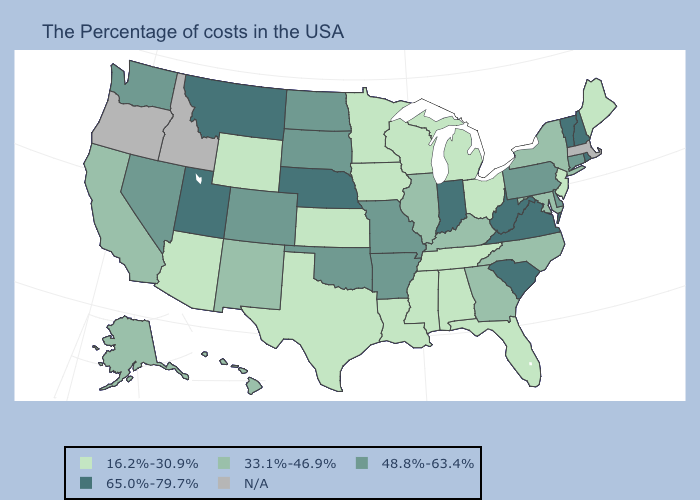What is the value of Illinois?
Give a very brief answer. 33.1%-46.9%. Is the legend a continuous bar?
Be succinct. No. Name the states that have a value in the range N/A?
Keep it brief. Massachusetts, Idaho, Oregon. Which states hav the highest value in the South?
Keep it brief. Virginia, South Carolina, West Virginia. What is the lowest value in states that border Maine?
Short answer required. 65.0%-79.7%. Among the states that border Michigan , does Wisconsin have the highest value?
Concise answer only. No. Name the states that have a value in the range 48.8%-63.4%?
Quick response, please. Connecticut, Delaware, Pennsylvania, Missouri, Arkansas, Oklahoma, South Dakota, North Dakota, Colorado, Nevada, Washington. Name the states that have a value in the range 48.8%-63.4%?
Concise answer only. Connecticut, Delaware, Pennsylvania, Missouri, Arkansas, Oklahoma, South Dakota, North Dakota, Colorado, Nevada, Washington. Does Vermont have the highest value in the Northeast?
Keep it brief. Yes. What is the value of New Jersey?
Answer briefly. 16.2%-30.9%. What is the lowest value in the USA?
Answer briefly. 16.2%-30.9%. What is the highest value in the Northeast ?
Write a very short answer. 65.0%-79.7%. 